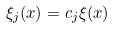<formula> <loc_0><loc_0><loc_500><loc_500>\xi _ { j } ( x ) = c _ { j } \xi ( x )</formula> 